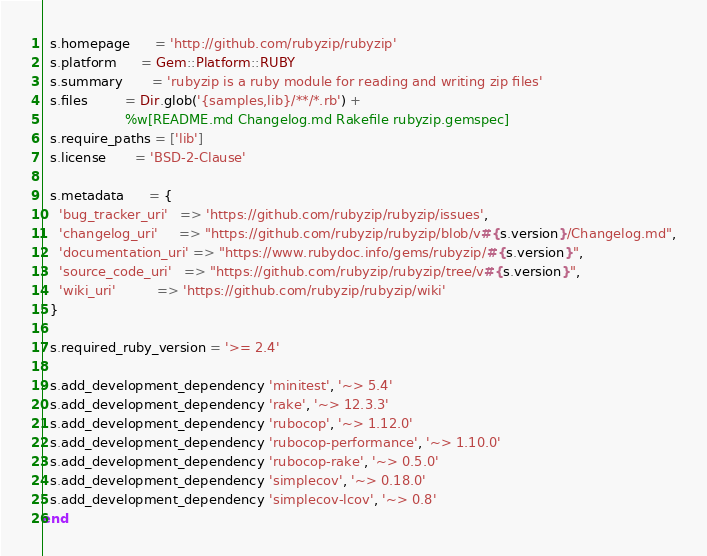<code> <loc_0><loc_0><loc_500><loc_500><_Ruby_>  s.homepage      = 'http://github.com/rubyzip/rubyzip'
  s.platform      = Gem::Platform::RUBY
  s.summary       = 'rubyzip is a ruby module for reading and writing zip files'
  s.files         = Dir.glob('{samples,lib}/**/*.rb') +
                    %w[README.md Changelog.md Rakefile rubyzip.gemspec]
  s.require_paths = ['lib']
  s.license       = 'BSD-2-Clause'

  s.metadata      = {
    'bug_tracker_uri'   => 'https://github.com/rubyzip/rubyzip/issues',
    'changelog_uri'     => "https://github.com/rubyzip/rubyzip/blob/v#{s.version}/Changelog.md",
    'documentation_uri' => "https://www.rubydoc.info/gems/rubyzip/#{s.version}",
    'source_code_uri'   => "https://github.com/rubyzip/rubyzip/tree/v#{s.version}",
    'wiki_uri'          => 'https://github.com/rubyzip/rubyzip/wiki'
  }

  s.required_ruby_version = '>= 2.4'

  s.add_development_dependency 'minitest', '~> 5.4'
  s.add_development_dependency 'rake', '~> 12.3.3'
  s.add_development_dependency 'rubocop', '~> 1.12.0'
  s.add_development_dependency 'rubocop-performance', '~> 1.10.0'
  s.add_development_dependency 'rubocop-rake', '~> 0.5.0'
  s.add_development_dependency 'simplecov', '~> 0.18.0'
  s.add_development_dependency 'simplecov-lcov', '~> 0.8'
end
</code> 